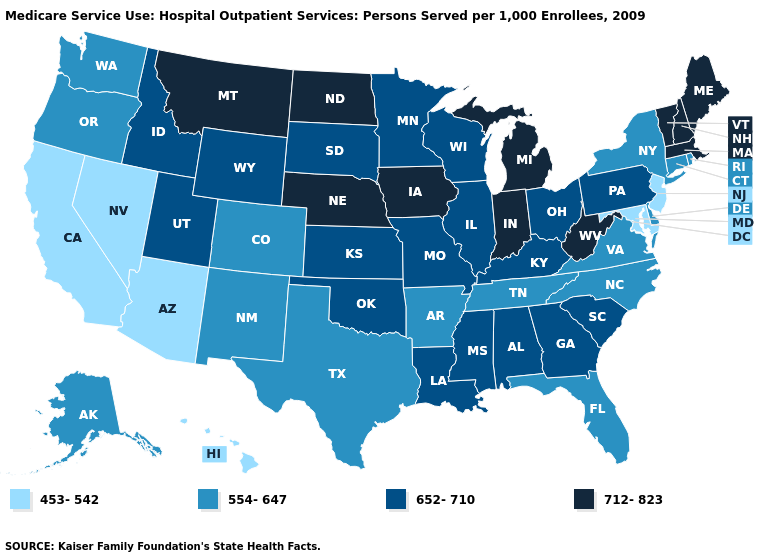Name the states that have a value in the range 712-823?
Answer briefly. Indiana, Iowa, Maine, Massachusetts, Michigan, Montana, Nebraska, New Hampshire, North Dakota, Vermont, West Virginia. Among the states that border Washington , does Oregon have the lowest value?
Quick response, please. Yes. Name the states that have a value in the range 453-542?
Be succinct. Arizona, California, Hawaii, Maryland, Nevada, New Jersey. What is the value of Idaho?
Quick response, please. 652-710. Name the states that have a value in the range 453-542?
Short answer required. Arizona, California, Hawaii, Maryland, Nevada, New Jersey. Does Virginia have the same value as Montana?
Be succinct. No. Which states hav the highest value in the Northeast?
Short answer required. Maine, Massachusetts, New Hampshire, Vermont. Name the states that have a value in the range 554-647?
Write a very short answer. Alaska, Arkansas, Colorado, Connecticut, Delaware, Florida, New Mexico, New York, North Carolina, Oregon, Rhode Island, Tennessee, Texas, Virginia, Washington. What is the value of Wisconsin?
Give a very brief answer. 652-710. Does the first symbol in the legend represent the smallest category?
Quick response, please. Yes. Does the map have missing data?
Write a very short answer. No. What is the value of Oklahoma?
Give a very brief answer. 652-710. Which states have the lowest value in the USA?
Concise answer only. Arizona, California, Hawaii, Maryland, Nevada, New Jersey. Among the states that border South Carolina , which have the lowest value?
Be succinct. North Carolina. Does Vermont have the same value as Oregon?
Write a very short answer. No. 